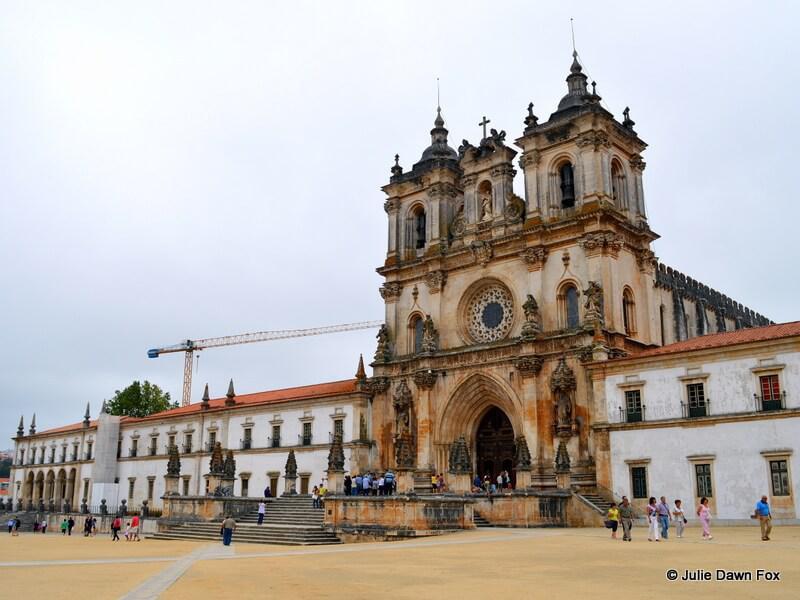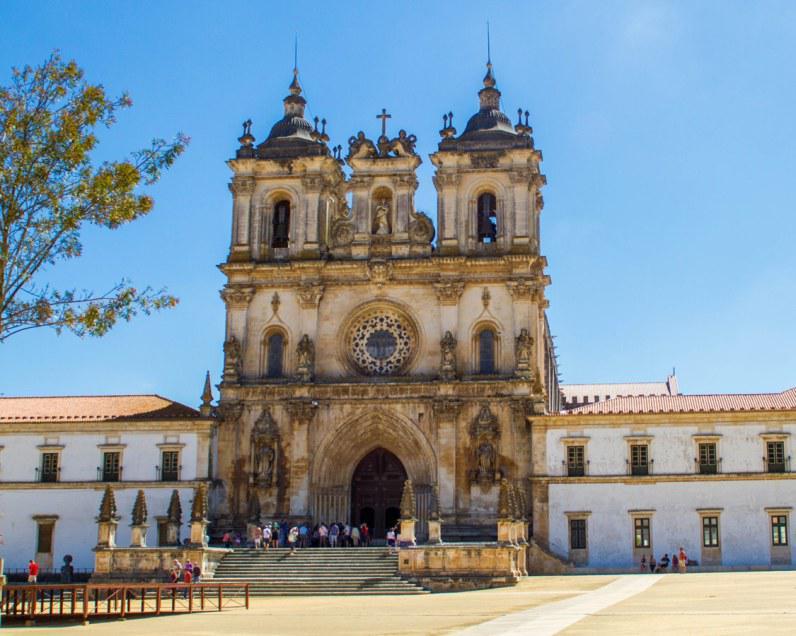The first image is the image on the left, the second image is the image on the right. For the images shown, is this caption "Both buildings share the same design." true? Answer yes or no. Yes. The first image is the image on the left, the second image is the image on the right. Given the left and right images, does the statement "Each image has people on the steps in front of the building." hold true? Answer yes or no. Yes. 